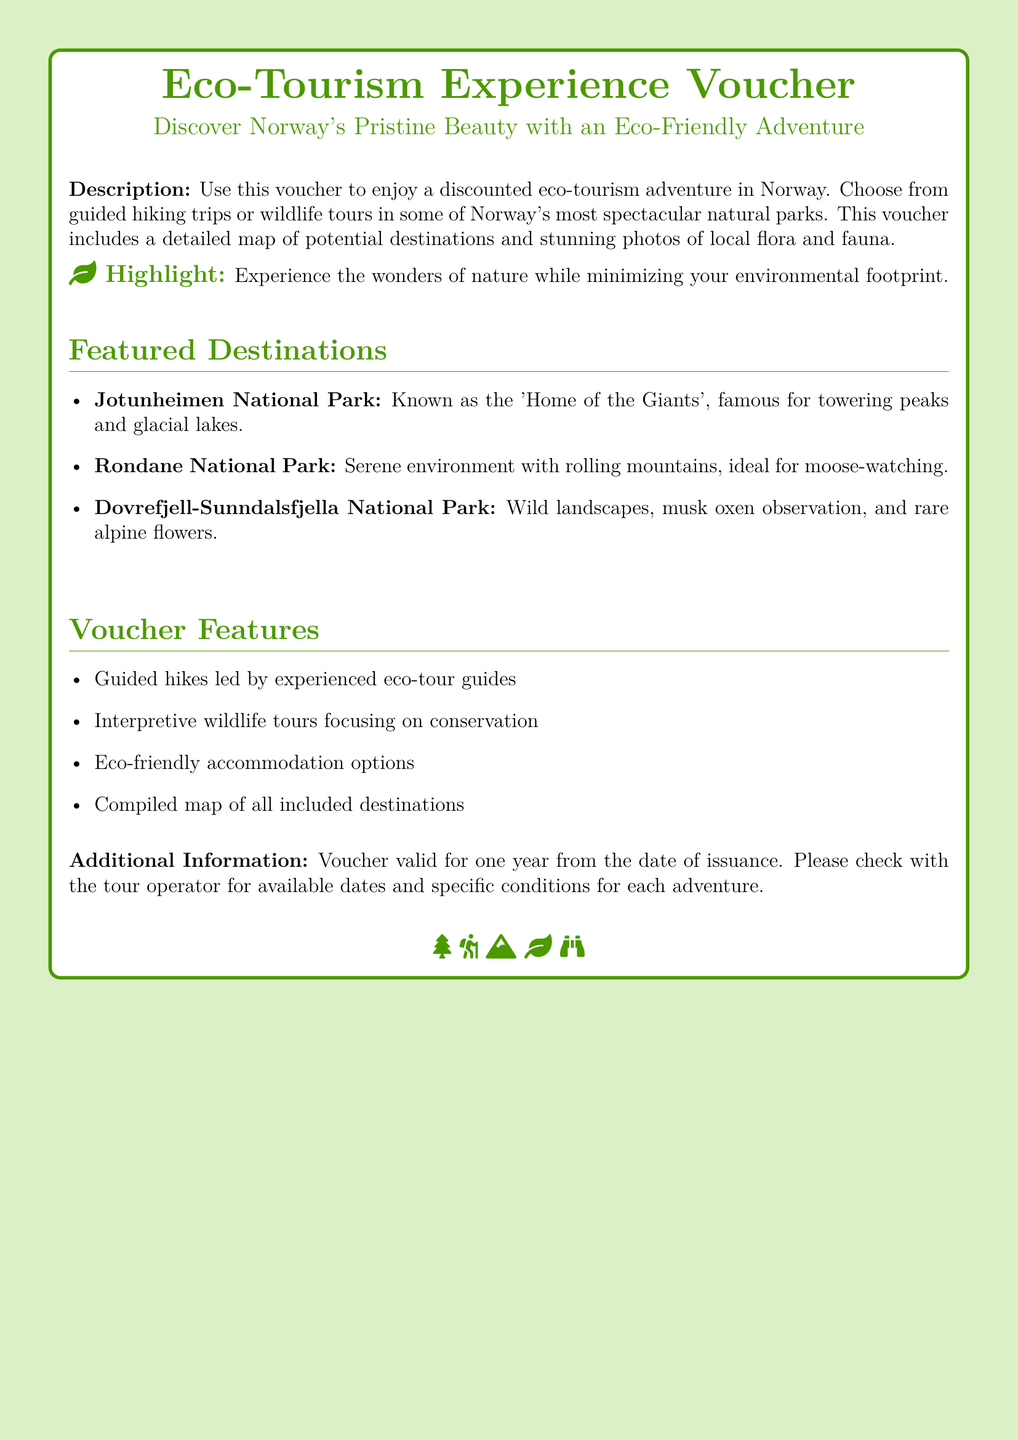What is the title of the voucher? The title is prominently displayed at the top of the document, stating the purpose of the gift provided.
Answer: Eco-Tourism Experience Voucher What type of adventures can this voucher be used for? The document describes the types of adventures available through the voucher, emphasizing eco-adventurous experiences.
Answer: Eco-tourism adventure Which national park is known as the 'Home of the Giants'? This information is found in the section detailing featured destinations, highlighting a specific park's nickname.
Answer: Jotunheimen National Park How long is the voucher valid for? The validity period for the voucher is explicitly stated in the additional information section of the document.
Answer: One year What is a highlight feature of using this voucher? The document emphasizes an important aspect focusing on environmentally friendly experiences in nature.
Answer: Minimizing your environmental footprint What type of accommodation options are available according to the voucher features? The voucher features mention specific types of accommodation, relating to environmental concerns.
Answer: Eco-friendly accommodation options How many featured destinations are listed? The number of destinations can be counted in the section detailing featured locations in the document.
Answer: Three What does the voucher include in addition to discounts on adventures? The additional benefits or contents provided with the voucher are noted underneath the description section.
Answer: A detailed map and stunning photos Which animal can you observe in Rondane National Park? The specific wildlife species mentioned in the context of this national park's features can answer this question.
Answer: Moose 